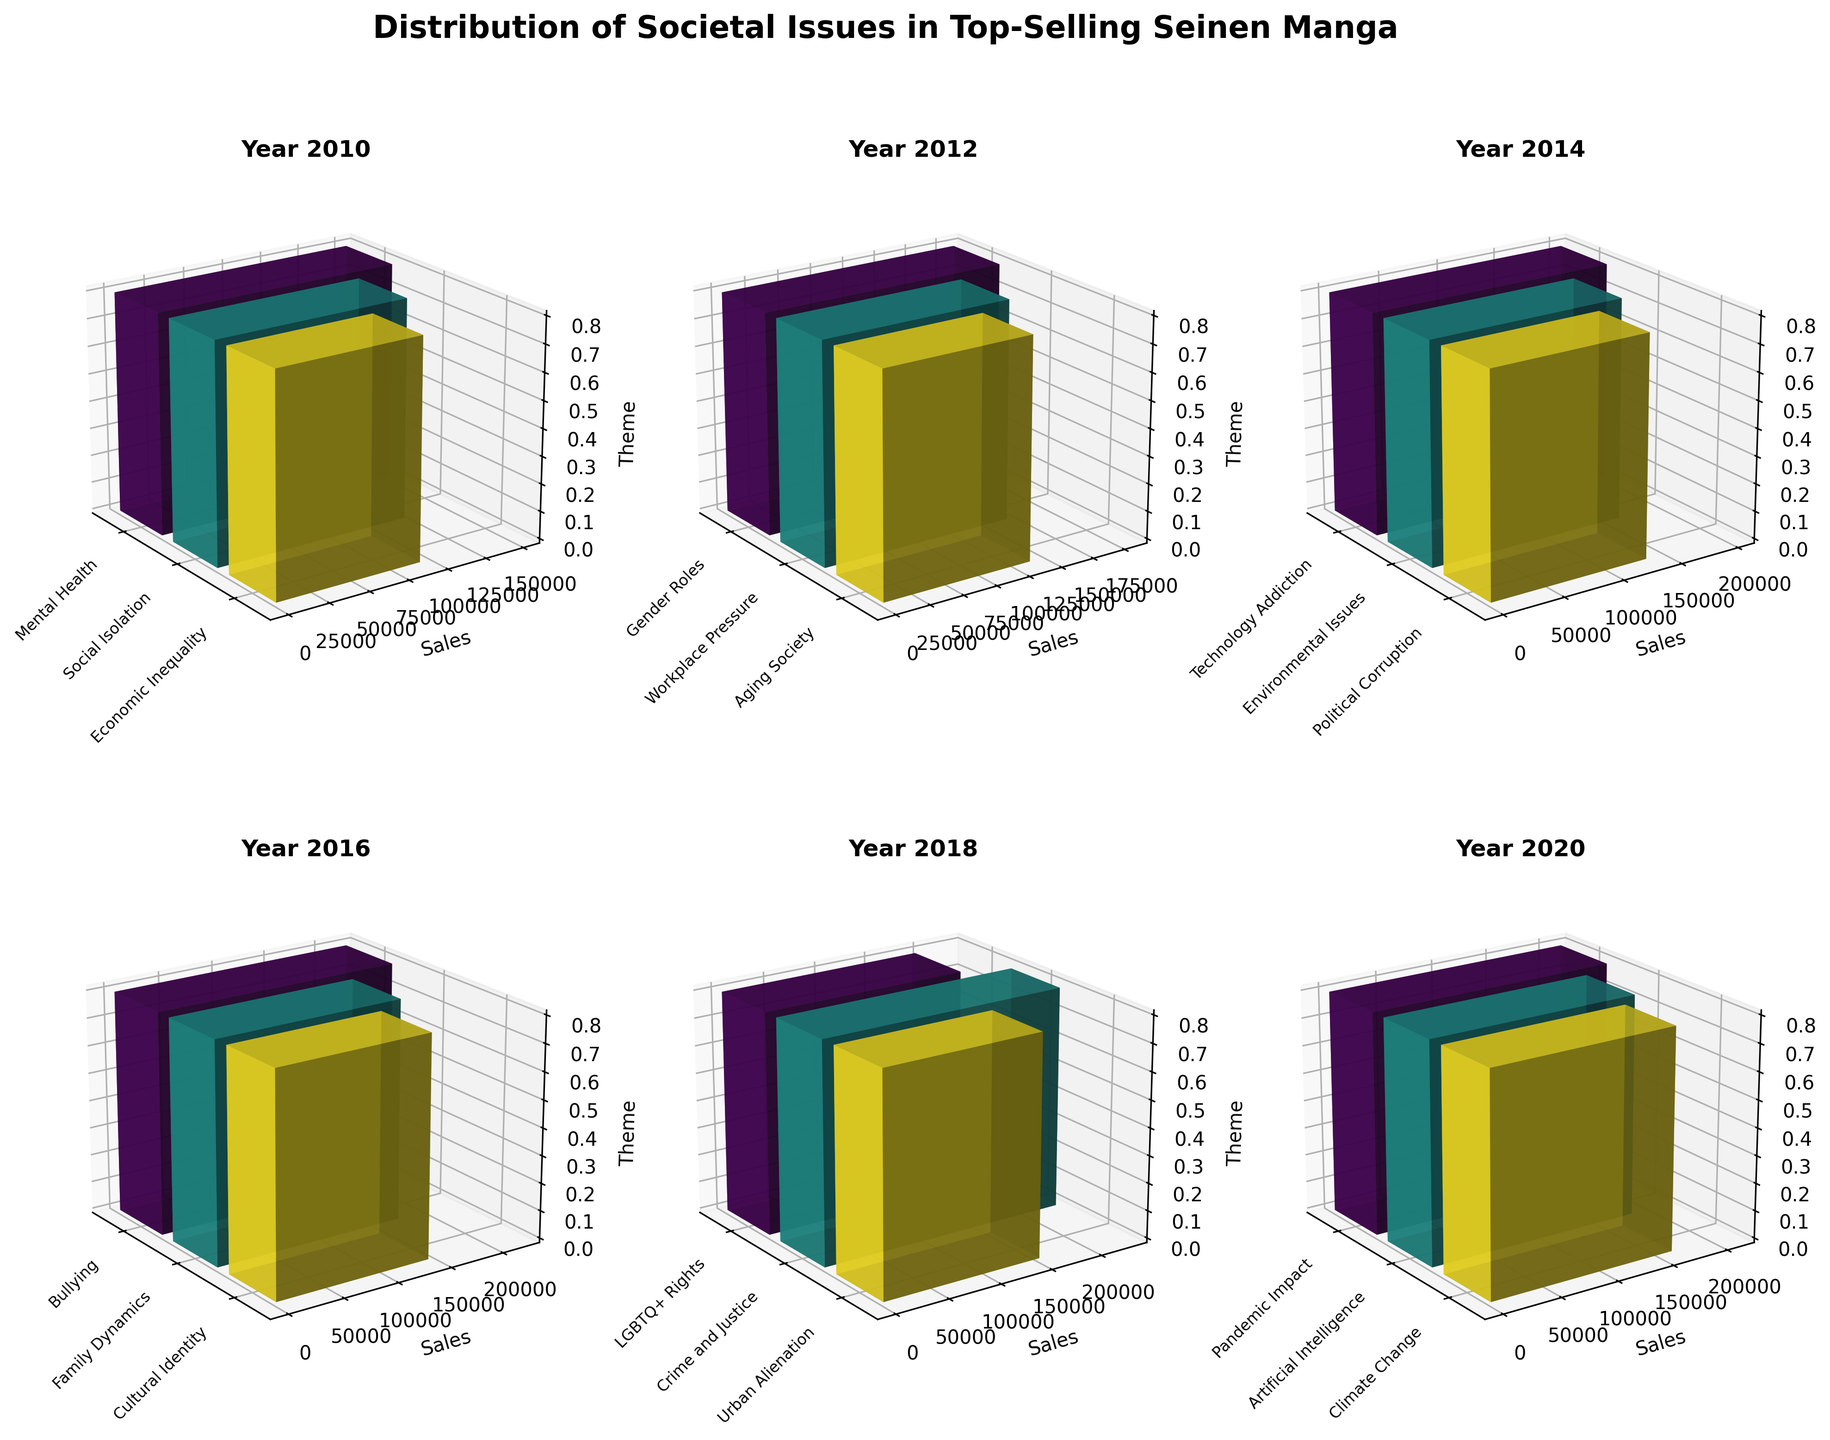What year has the theme "Bullying" addressed in the top-selling seinen manga titles? Look for the theme "Bullying" in the 3D subplot, identify which year's plot it appears in. The theme "Bullying" is addressed in the year 2016.
Answer: 2016 Which theme in the year 2020 had the highest sales? For the year 2020 subplot, examine the heights of the bars to determine the theme with the highest sales. "Pandemic Impact" had the highest sales in 2020.
Answer: Pandemic Impact How many different themes are addressed in manga published in 2014? Count the number of different bars (themes) in the subplot for the year 2014. There are three themes addressed in 2014.
Answer: 3 Which year had the theme with the lowest sales overall, and what was the theme? Compare the heights of the lowest bar across all subplots to identify the year and corresponding theme. The year 2010 had the theme "Economic Inequality" with the lowest sales.
Answer: 2010, Economic Inequality What is the combined sales figure for the themes "Mental Health" and "Social Isolation" in 2010? Locate the bars for these themes in the 2010 subplot, then sum their sales. For 2010, "Mental Health" had 150,000 and "Social Isolation" had 120,000 sales. Combined, they total 270,000.
Answer: 270,000 Which theme in the year 2018 had higher sales: "LGBTQ+ Rights" or "Crime and Justice"? Compare the heights of the bars for "LGBTQ+ Rights" and "Crime and Justice" in the 2018 subplot. "Crime and Justice" had higher sales than "LGBTQ+ Rights" in 2018.
Answer: Crime and Justice In which years is the theme of technology addressed, and what are their themes? Identify the subplots where technology-related themes are present and name them. Technology-related themes are addressed in 2014 with "Technology Addiction" and in 2020 with "Artificial Intelligence."
Answer: 2014, 2020 Compare the sales for "Workplace Pressure" in 2012 and "Urban Alienation" in 2018. Which one is higher? Examine the bar heights for "Workplace Pressure" in 2012 and "Urban Alienation" in 2018, and compare them. "Urban Alienation" in 2018 has higher sales than "Workplace Pressure" in 2012.
Answer: Urban Alienation in 2018 